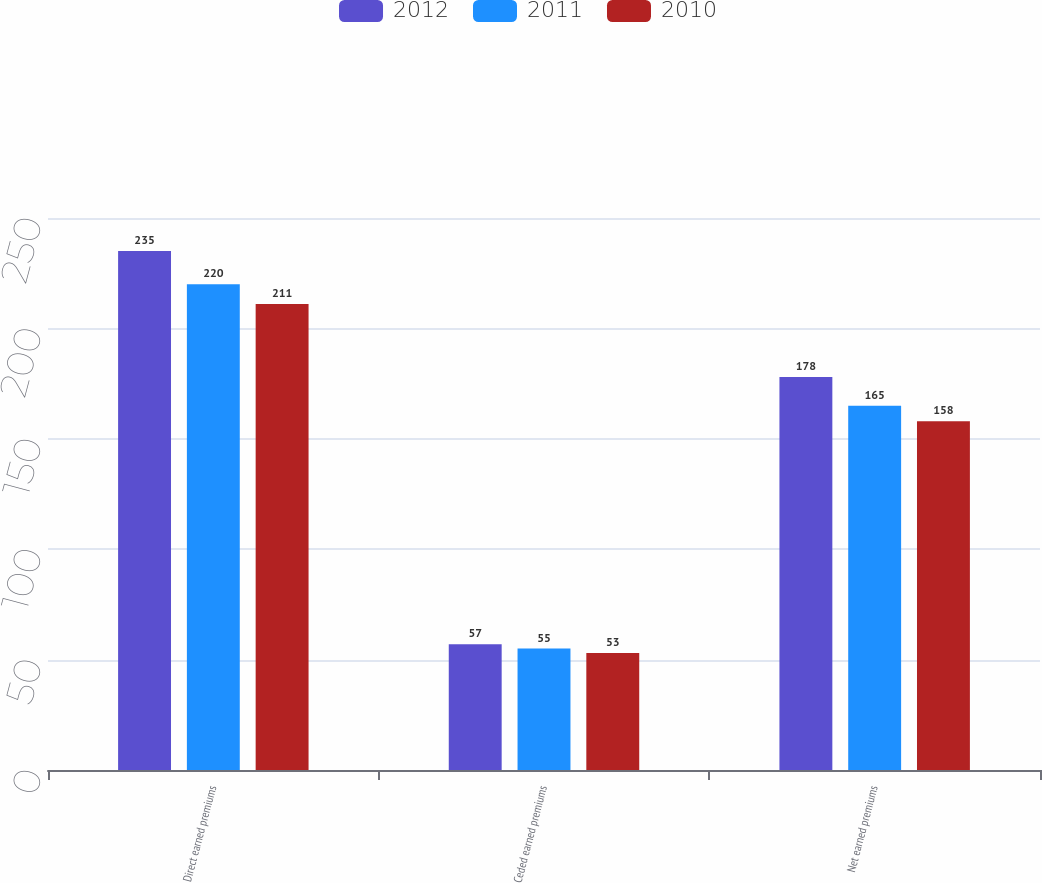<chart> <loc_0><loc_0><loc_500><loc_500><stacked_bar_chart><ecel><fcel>Direct earned premiums<fcel>Ceded earned premiums<fcel>Net earned premiums<nl><fcel>2012<fcel>235<fcel>57<fcel>178<nl><fcel>2011<fcel>220<fcel>55<fcel>165<nl><fcel>2010<fcel>211<fcel>53<fcel>158<nl></chart> 